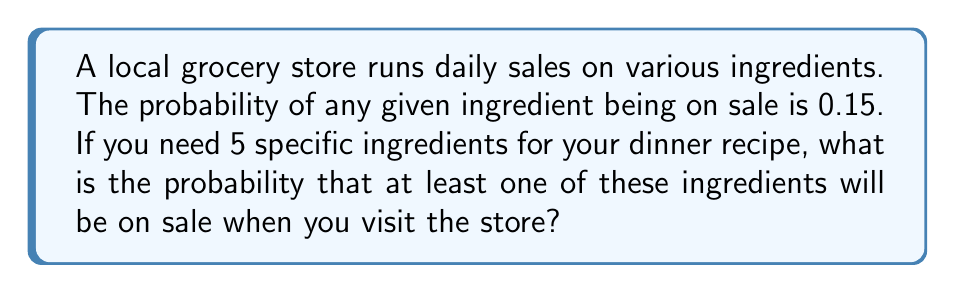Help me with this question. Let's approach this step-by-step:

1) First, let's consider the probability that a specific ingredient is not on sale. If the probability of being on sale is 0.15, then the probability of not being on sale is:

   $1 - 0.15 = 0.85$

2) Now, for all 5 ingredients to not be on sale, each of them must independently not be on sale. The probability of this is:

   $0.85^5 = 0.4437$

3) Therefore, the probability of at least one ingredient being on sale is the opposite of all ingredients not being on sale:

   $1 - 0.4437 = 0.5563$

4) We can also calculate this using the complement rule:

   $P(\text{at least one on sale}) = 1 - P(\text{none on sale})$

   $= 1 - (1 - 0.15)^5$

   $= 1 - 0.85^5$

   $= 1 - 0.4437 = 0.5563$

Thus, the probability of finding at least one of the five needed ingredients on sale is approximately 0.5563 or 55.63%.
Answer: $0.5563$ or $55.63\%$ 